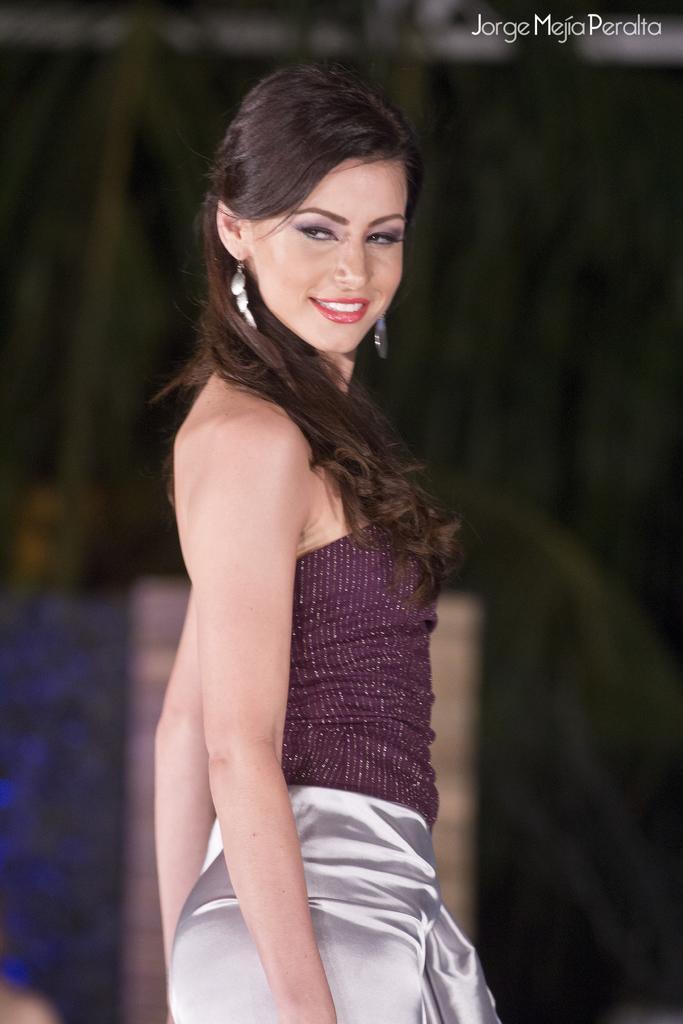Please provide a concise description of this image. In this picture I can see a woman standing in front and I see that, she is wearing maroon and silver color dress. On the top right corner of this picture, I can see the watermark and I see that it is blurred in the background. 